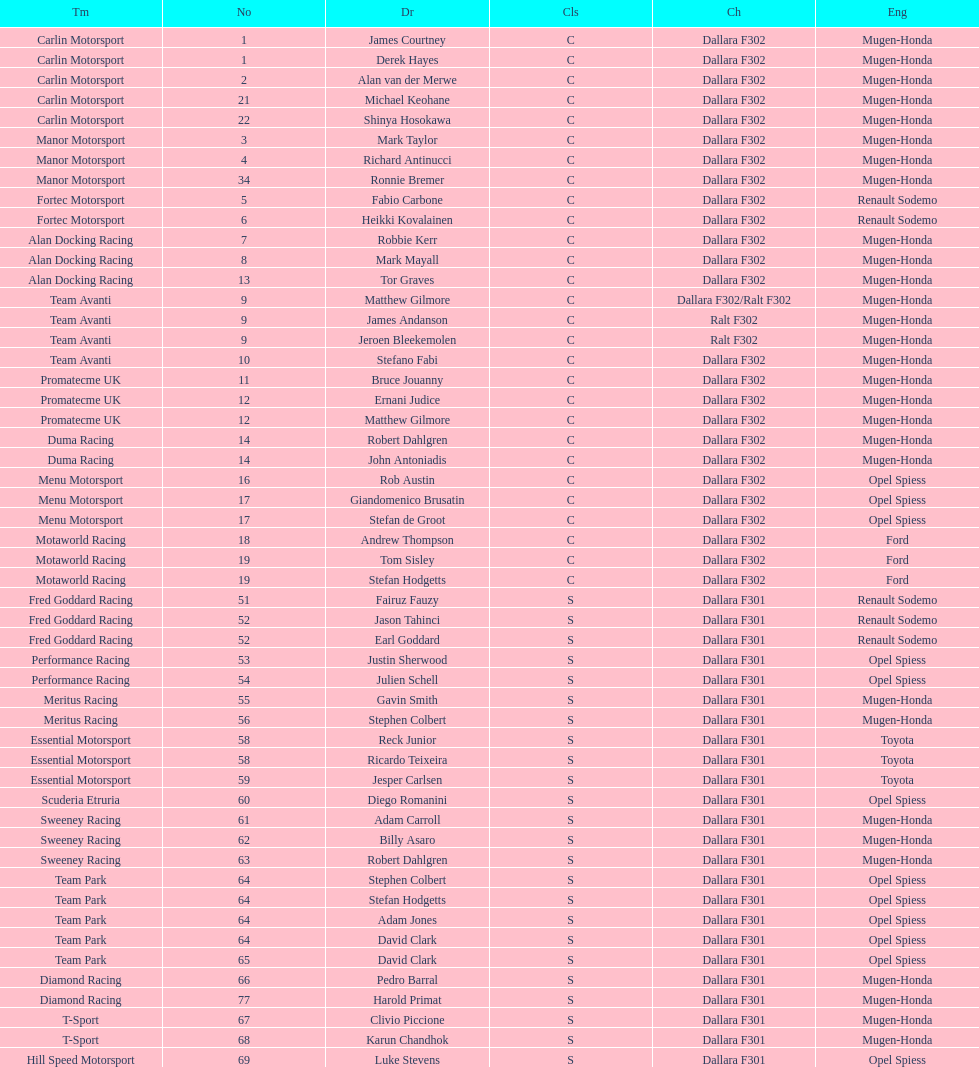What is the number of teams that had drivers all from the same country? 4. Parse the table in full. {'header': ['Tm', 'No', 'Dr', 'Cls', 'Ch', 'Eng'], 'rows': [['Carlin Motorsport', '1', 'James Courtney', 'C', 'Dallara F302', 'Mugen-Honda'], ['Carlin Motorsport', '1', 'Derek Hayes', 'C', 'Dallara F302', 'Mugen-Honda'], ['Carlin Motorsport', '2', 'Alan van der Merwe', 'C', 'Dallara F302', 'Mugen-Honda'], ['Carlin Motorsport', '21', 'Michael Keohane', 'C', 'Dallara F302', 'Mugen-Honda'], ['Carlin Motorsport', '22', 'Shinya Hosokawa', 'C', 'Dallara F302', 'Mugen-Honda'], ['Manor Motorsport', '3', 'Mark Taylor', 'C', 'Dallara F302', 'Mugen-Honda'], ['Manor Motorsport', '4', 'Richard Antinucci', 'C', 'Dallara F302', 'Mugen-Honda'], ['Manor Motorsport', '34', 'Ronnie Bremer', 'C', 'Dallara F302', 'Mugen-Honda'], ['Fortec Motorsport', '5', 'Fabio Carbone', 'C', 'Dallara F302', 'Renault Sodemo'], ['Fortec Motorsport', '6', 'Heikki Kovalainen', 'C', 'Dallara F302', 'Renault Sodemo'], ['Alan Docking Racing', '7', 'Robbie Kerr', 'C', 'Dallara F302', 'Mugen-Honda'], ['Alan Docking Racing', '8', 'Mark Mayall', 'C', 'Dallara F302', 'Mugen-Honda'], ['Alan Docking Racing', '13', 'Tor Graves', 'C', 'Dallara F302', 'Mugen-Honda'], ['Team Avanti', '9', 'Matthew Gilmore', 'C', 'Dallara F302/Ralt F302', 'Mugen-Honda'], ['Team Avanti', '9', 'James Andanson', 'C', 'Ralt F302', 'Mugen-Honda'], ['Team Avanti', '9', 'Jeroen Bleekemolen', 'C', 'Ralt F302', 'Mugen-Honda'], ['Team Avanti', '10', 'Stefano Fabi', 'C', 'Dallara F302', 'Mugen-Honda'], ['Promatecme UK', '11', 'Bruce Jouanny', 'C', 'Dallara F302', 'Mugen-Honda'], ['Promatecme UK', '12', 'Ernani Judice', 'C', 'Dallara F302', 'Mugen-Honda'], ['Promatecme UK', '12', 'Matthew Gilmore', 'C', 'Dallara F302', 'Mugen-Honda'], ['Duma Racing', '14', 'Robert Dahlgren', 'C', 'Dallara F302', 'Mugen-Honda'], ['Duma Racing', '14', 'John Antoniadis', 'C', 'Dallara F302', 'Mugen-Honda'], ['Menu Motorsport', '16', 'Rob Austin', 'C', 'Dallara F302', 'Opel Spiess'], ['Menu Motorsport', '17', 'Giandomenico Brusatin', 'C', 'Dallara F302', 'Opel Spiess'], ['Menu Motorsport', '17', 'Stefan de Groot', 'C', 'Dallara F302', 'Opel Spiess'], ['Motaworld Racing', '18', 'Andrew Thompson', 'C', 'Dallara F302', 'Ford'], ['Motaworld Racing', '19', 'Tom Sisley', 'C', 'Dallara F302', 'Ford'], ['Motaworld Racing', '19', 'Stefan Hodgetts', 'C', 'Dallara F302', 'Ford'], ['Fred Goddard Racing', '51', 'Fairuz Fauzy', 'S', 'Dallara F301', 'Renault Sodemo'], ['Fred Goddard Racing', '52', 'Jason Tahinci', 'S', 'Dallara F301', 'Renault Sodemo'], ['Fred Goddard Racing', '52', 'Earl Goddard', 'S', 'Dallara F301', 'Renault Sodemo'], ['Performance Racing', '53', 'Justin Sherwood', 'S', 'Dallara F301', 'Opel Spiess'], ['Performance Racing', '54', 'Julien Schell', 'S', 'Dallara F301', 'Opel Spiess'], ['Meritus Racing', '55', 'Gavin Smith', 'S', 'Dallara F301', 'Mugen-Honda'], ['Meritus Racing', '56', 'Stephen Colbert', 'S', 'Dallara F301', 'Mugen-Honda'], ['Essential Motorsport', '58', 'Reck Junior', 'S', 'Dallara F301', 'Toyota'], ['Essential Motorsport', '58', 'Ricardo Teixeira', 'S', 'Dallara F301', 'Toyota'], ['Essential Motorsport', '59', 'Jesper Carlsen', 'S', 'Dallara F301', 'Toyota'], ['Scuderia Etruria', '60', 'Diego Romanini', 'S', 'Dallara F301', 'Opel Spiess'], ['Sweeney Racing', '61', 'Adam Carroll', 'S', 'Dallara F301', 'Mugen-Honda'], ['Sweeney Racing', '62', 'Billy Asaro', 'S', 'Dallara F301', 'Mugen-Honda'], ['Sweeney Racing', '63', 'Robert Dahlgren', 'S', 'Dallara F301', 'Mugen-Honda'], ['Team Park', '64', 'Stephen Colbert', 'S', 'Dallara F301', 'Opel Spiess'], ['Team Park', '64', 'Stefan Hodgetts', 'S', 'Dallara F301', 'Opel Spiess'], ['Team Park', '64', 'Adam Jones', 'S', 'Dallara F301', 'Opel Spiess'], ['Team Park', '64', 'David Clark', 'S', 'Dallara F301', 'Opel Spiess'], ['Team Park', '65', 'David Clark', 'S', 'Dallara F301', 'Opel Spiess'], ['Diamond Racing', '66', 'Pedro Barral', 'S', 'Dallara F301', 'Mugen-Honda'], ['Diamond Racing', '77', 'Harold Primat', 'S', 'Dallara F301', 'Mugen-Honda'], ['T-Sport', '67', 'Clivio Piccione', 'S', 'Dallara F301', 'Mugen-Honda'], ['T-Sport', '68', 'Karun Chandhok', 'S', 'Dallara F301', 'Mugen-Honda'], ['Hill Speed Motorsport', '69', 'Luke Stevens', 'S', 'Dallara F301', 'Opel Spiess']]} 